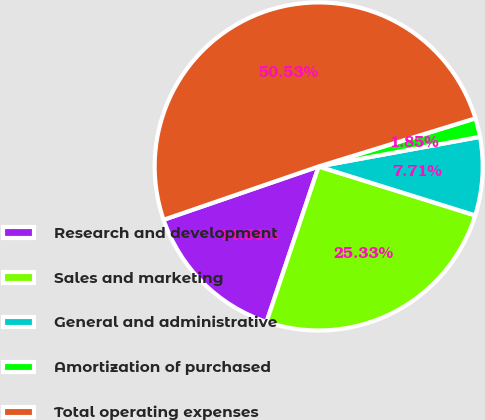<chart> <loc_0><loc_0><loc_500><loc_500><pie_chart><fcel>Research and development<fcel>Sales and marketing<fcel>General and administrative<fcel>Amortization of purchased<fcel>Total operating expenses<nl><fcel>14.58%<fcel>25.33%<fcel>7.71%<fcel>1.85%<fcel>50.53%<nl></chart> 